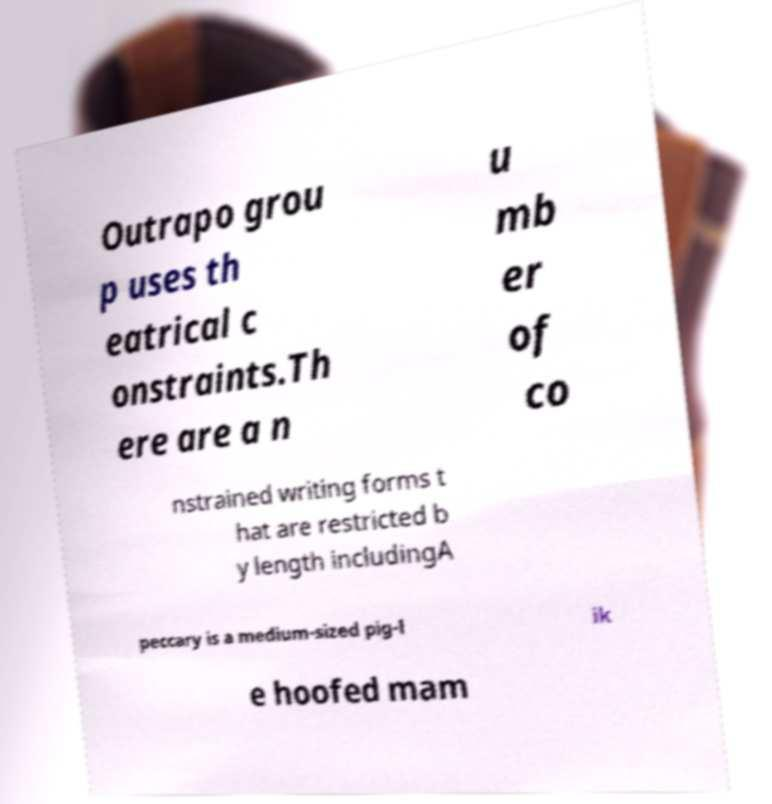Can you read and provide the text displayed in the image?This photo seems to have some interesting text. Can you extract and type it out for me? Outrapo grou p uses th eatrical c onstraints.Th ere are a n u mb er of co nstrained writing forms t hat are restricted b y length includingA peccary is a medium-sized pig-l ik e hoofed mam 